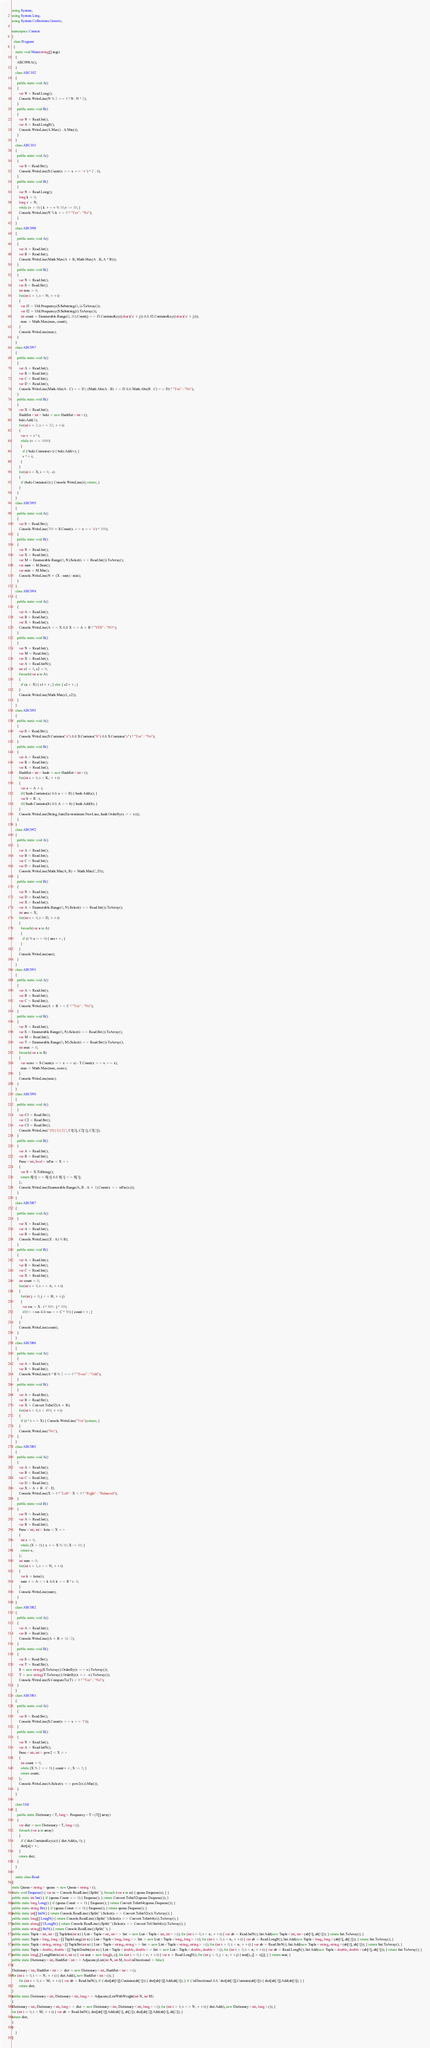Convert code to text. <code><loc_0><loc_0><loc_500><loc_500><_C#_>using System;
using System.Linq;
using System.Collections.Generic;

namespace Contest
{
  class Program
  {
    static void Main(string[] args)
    {
      ABC098.A();
    }
    class ABC102
    {
      public static void A()
      {
        var N = Read.Long();
        Console.WriteLine(N % 2 == 0 ? N : N * 2);
      }
      public static void B()
      {
        var N = Read.Int();
        var A = Read.LongN();
        Console.WriteLine(A.Max() - A.Min());
      }
    }
    class ABC101
    {
      public static void A()
      {
        var S = Read.Str();
        Console.WriteLine(S.Count(x => x == '+') * 2 - 4);
      }
      public static void B()
      {
        var N = Read.Long();
        long k = 0;
        long v = N;
        while (v > 0) { k += v % 10;v /= 10; }
        Console.WriteLine(N % k == 0 ? "Yes" : "No");
      }
    }
    class ABC098
    {
      public static void A()
      {
        var A = Read.Int();
        var B = Read.Int();
        Console.WriteLine(Math.Max(A + B, Math.Max(A - B, A * B)));
      }
      public static void B()
      {
        var N = Read.Int();
        var S = Read.Str();
        int max = 0;
        for(int i = 1; i < N; ++i)
        {
          var f1 = Util.Frequency(S.Substring(0, i).ToArray());
          var f2 = Util.Frequency(S.Substring(i).ToArray());
          int count = Enumerable.Range(0, 26).Count(j => f1.ContainsKey((char)('a' + j)) && f2.ContainsKey((char)('a' + j)));
          max = Math.Max(max, count);
        }
        Console.WriteLine(max);
      }
    }
    class ABC097
    {
      public static void A()
      {
        var A = Read.Int();
        var B = Read.Int();
        var C = Read.Int();
        var D = Read.Int();
        Console.WriteLine(Math.Abs(A - C) <= D || (Math.Abs(A - B) <= D && Math.Abs(B - C) <= D) ? "Yes" : "No");
      }
      public static void B()
      {
        var X = Read.Int();
        HashSet<int> beki = new HashSet<int>();
        beki.Add(1);
        for(int i = 2; i <= 32; ++i)
        {
          var v = i * i;
          while (v <= 1000)
          {
            if (!beki.Contains(v)) { beki.Add(v); }
            v *= i;
          }
        }
        for(int i = X; i > 0; --i)
        {
          if (beki.Contains(i)) { Console.WriteLine(i); return; }
        }
      }
    }
    class ABC095
    {
      public static void A()
      {
        var S = Read.Str();
        Console.WriteLine(700 + S.Count(x => x == 'o') * 100);
      }
      public static void B()
      {
        var N = Read.Int();
        var X = Read.Int();
        var M = Enumerable.Range(0, N).Select(i => Read.Int()).ToArray();
        var sum = M.Sum();
        var min = M.Min();
        Console.WriteLine(N + (X - sum) / min);
      }
    }
    class ABC094
    {
      public static void A()
      {
        var A = Read.Int();
        var B = Read.Int();
        var X = Read.Int();
        Console.WriteLine(A <= X && X <= A + B ? "YES" : "NO");
      }
      public static void B()
      {
        var N = Read.Int();
        var M = Read.Int();
        var X = Read.Int();
        var A = Read.IntN();
        int c1 = 0, c2 = 0;
        foreach(var a in A)
        {
          if (a < X) { c1++; } else { c2++; }
        }
        Console.WriteLine(Math.Min(c1, c2));
      }
    }
    class ABC093
    {
      public static void A()
      {
        var S = Read.Str();
        Console.WriteLine(S.Contains("a") && S.Contains("b") && S.Contains("c") ? "Yes" : "No");
      }
      public static void B()
      {
        var A = Read.Int();
        var B = Read.Int();
        var K = Read.Int();
        HashSet<int> hash = new HashSet<int>();
        for(int i = 0; i < K; ++i)
        {
          var a = A + i;
          if(!hash.Contains(a) && a <= B) { hash.Add(a); }
          var b = B - i;
          if(!hash.Contains(b) && A <= b) { hash.Add(b); }
        }
        Console.WriteLine(String.Join(Environment.NewLine, hash.OrderBy(x => x)));
      }
    }
    class ABC092
    {
      public static void A()
      {
        var A = Read.Int();
        var B = Read.Int();
        var C = Read.Int();
        var D = Read.Int();
        Console.WriteLine(Math.Min(A, B) + Math.Min(C, D));
      }
      public static void B()
      {
        var N = Read.Int();
        var D = Read.Int();
        var X = Read.Int();
        var A = Enumerable.Range(0, N).Select(i => Read.Int()).ToArray();
        int ans = X;
        for(int i = 0; i < D; ++i)
        {
          foreach(var a in A)
          {
            if (i % a == 0) { ans++; }
          }
        }
        Console.WriteLine(ans);
      }
    }
    class ABC091
    {
      public static void A()
      {
        var A = Read.Int();
        var B = Read.Int();
        var C = Read.Int();
        Console.WriteLine(A + B >= C ? "Yes" : "No");
      }
      public static void B()
      {
        var N = Read.Int();
        var S = Enumerable.Range(0, N).Select(i => Read.Str()).ToArray();
        var M = Read.Int();
        var T = Enumerable.Range(0, M).Select(i => Read.Str()).ToArray();
        int max = 0;
        foreach(var s in S)
        {
          var score = S.Count(x => x == s) - T.Count(x => x == s);
          max = Math.Max(max, score);
        }
        Console.WriteLine(max);
      }
    }
    class ABC090
    {
      public static void A()
      {
        var C1 = Read.Str();
        var C2 = Read.Str();
        var C3 = Read.Str();
        Console.WriteLine("{0}{1}{2}", C1[0], C2[1], C3[2]);
      }
      public static void B()
      {
        var A = Read.Int();
        var B = Read.Int();
        Func<int, bool> isPar = X =>
        {
          var S = X.ToString();
          return S[0] == S[4] && S[1] == S[3];
        };
        Console.WriteLine(Enumerable.Range(A, B - A + 1).Count(x => isPar(x)));
      }
    }
    class ABC087
    {
      public static void A()
      {
        var X = Read.Int();
        var A = Read.Int();
        var B = Read.Int();
        Console.WriteLine((X - A) % B);
      }
      public static void B()
      {
        var A = Read.Int();
        var B = Read.Int();
        var C = Read.Int();
        var X = Read.Int();
        int count = 0;
        for(int i = 0; i <= A; ++i)
        {
          for(int j = 0; j <= B; ++j)
          {
            var res = X - i * 500 - j * 100;
            if(0<=res && res <= C * 50) { count++; }
          }
        }
        Console.WriteLine(count);
      }
    }
    class ABC086
    {
      public static void A()
      {
        var A = Read.Int();
        var B = Read.Int();
        Console.WriteLine(A * B % 2 == 0 ? "Even" : "Odd");
      }
      public static void B()
      {
        var A = Read.Str();
        var B = Read.Str();
        var X = Convert.ToInt32(A + B);
        for(int i = 0; i < 400; ++i)
        {
          if (i * i == X) { Console.WriteLine("Yes");return; }
        }
        Console.WriteLine("No");
      }
    }
    class ABC083
    {
      public static void A()
      {
        var A = Read.Int();
        var B = Read.Int();
        var C = Read.Int();
        var D = Read.Int();
        var X = A + B - C - D;
        Console.WriteLine(X > 0 ? "Left" : X < 0 ? "Right" : "Balanced");
      }
      public static void B()
      {
        var N = Read.Int();
        var A = Read.Int();
        var B = Read.Int();
        Func<int, int> keta = X =>
        {
          int x = 0;
          while (X > 0) { x += X % 10; X /= 10; }
          return x;
        };
        int sum = 0;
        for(int i = 1; i <= N; ++i)
        {
          var k = keta(i);
          sum += A <= k && k <= B ? i : 0;
        }
        Console.WriteLine(sum);
      }
    }
    class ABC082
    {
      public static void A()
      {
        var A = Read.Int();
        var B = Read.Int();
        Console.WriteLine((A + B + 1) / 2);
      }
      public static void B()
      {
        var S = Read.Str();
        var T = Read.Str();
        S = new string(S.ToArray().OrderBy(x => x).ToArray());
        T = new string(T.ToArray().OrderBy(x => -x).ToArray());
        Console.WriteLine(S.CompareTo(T) < 0 ? "Yes" : "No");
      }
    }
    class ABC081
    {
      public static void A()
      {
        var S = Read.Str();
        Console.WriteLine(S.Count(x => x == '1'));
      }
      public static void B()
      {
        var N = Read.Int();
        var A = Read.IntN();
        Func<int, int> pow2 = X =>
        {
          int count = 0;
          while (X % 2 == 0) { count++; X /= 2; }
          return count;
        };
        Console.WriteLine(A.Select(x => pow2(x)).Min());
      }
    }

    class Util
    {
      public static Dictionary<T, long> Frequency<T>(T[] array)
      {
        var dict = new Dictionary<T, long>();
        foreach (var a in array)
        {
          if (!dict.ContainsKey(a)) { dict.Add(a, 0); }
          dict[a]++;
        }
        return dict;
      }
    }

    static class Read
{
static Queue<string> queue = new Queue<string>();
static void Enqueue() { var ss = Console.ReadLine().Split(' '); foreach (var s in ss) { queue.Enqueue(s); } }
public static int Int() { if (queue.Count == 0) { Enqueue(); } return Convert.ToInt32(queue.Dequeue()); }
public static long Long() { if (queue.Count == 0) { Enqueue(); } return Convert.ToInt64(queue.Dequeue()); }
public static string Str() { if (queue.Count == 0) { Enqueue(); } return queue.Dequeue(); }
public static int[] IntN() { return Console.ReadLine().Split(' ').Select(s => Convert.ToInt32(s)).ToArray(); }
public static long[] LongN() { return Console.ReadLine().Split(' ').Select(s => Convert.ToInt64(s)).ToArray(); }
public static ulong[] ULongN() { return Console.ReadLine().Split(' ').Select(s => Convert.ToUInt64(s)).ToArray(); }
public static string[] StrN() { return Console.ReadLine().Split(' '); }
public static Tuple<int, int>[] TupleInt(int n) { List<Tuple<int, int>> list = new List<Tuple<int, int>>(); for (int i = 0; i < n; ++i) { var ab = Read.IntN(); list.Add(new Tuple<int, int>(ab[0], ab[1])); } return list.ToArray(); }
public static Tuple<long, long>[] TupleLong(int n) { List<Tuple<long, long>> list = new List<Tuple<long, long>>(); for (int i = 0; i < n; ++i) { var ab = Read.LongN(); list.Add(new Tuple<long, long>(ab[0], ab[1])); } return list.ToArray(); }
public static Tuple<string, string>[] TupleStr(int n) { List<Tuple<string, string>> list = new List<Tuple<string, string>>(); for (int i = 0; i < n; ++i) { var ab = Read.StrN(); list.Add(new Tuple<string, string>(ab[0], ab[1])); } return list.ToArray(); }
public static Tuple<double, double>[] TupleDouble(int n) { List<Tuple<double, double>> list = new List<Tuple<double, double>>(); for (int i = 0; i < n; ++i) { var ab = Read.LongN(); list.Add(new Tuple<double, double>(ab[0], ab[1])); } return list.ToArray(); }
public static long[,] LongMatrix(int r, int c) { var mat = new long[r, c]; for (int i = 0; i < r; ++i) { var x = Read.LongN(); for (int j = 0; j < c; ++j) { mat[i, j] = x[j]; } } return mat; }
public static Dictionary<int, HashSet<int>> AdjacencyList(int N, int M, bool isDirectional = false)
{
Dictionary<int, HashSet<int>> dict = new Dictionary<int, HashSet<int>>();
for (int i = 0; i <= N; ++i) { dict.Add(i, new HashSet<int>()); }
        for (int i = 0; i < M; ++i) { var ab = Read.IntN(); if (!dict[ab[0]].Contains(ab[1])) { dict[ab[0]].Add(ab[1]); } if (!isDirectional && !dict[ab[1]].Contains(ab[0])) { dict[ab[1]].Add(ab[0]); } }
        return dict;
}
public static Dictionary<int, Dictionary<int, long>> AdjacencyListWithWeight(int N, int M)
{
Dictionary<int, Dictionary<int, long>> dict = new Dictionary<int, Dictionary<int, long>>(); for (int i = 0; i <= N; ++i) { dict.Add(i, new Dictionary<int, long>()); }
for (int i = 0; i < M; ++i) { var ab = Read.IntN(); dict[ab[0]].Add(ab[1], ab[2]); dict[ab[1]].Add(ab[0], ab[2]); }
return dict;
}
}
    }
}
</code> 